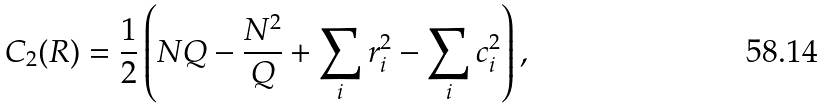<formula> <loc_0><loc_0><loc_500><loc_500>C _ { 2 } ( R ) = { \frac { 1 } { 2 } } \left ( N Q - { \frac { N ^ { 2 } } { Q } } + \sum _ { i } r _ { i } ^ { 2 } - \sum _ { i } c _ { i } ^ { 2 } \right ) ,</formula> 